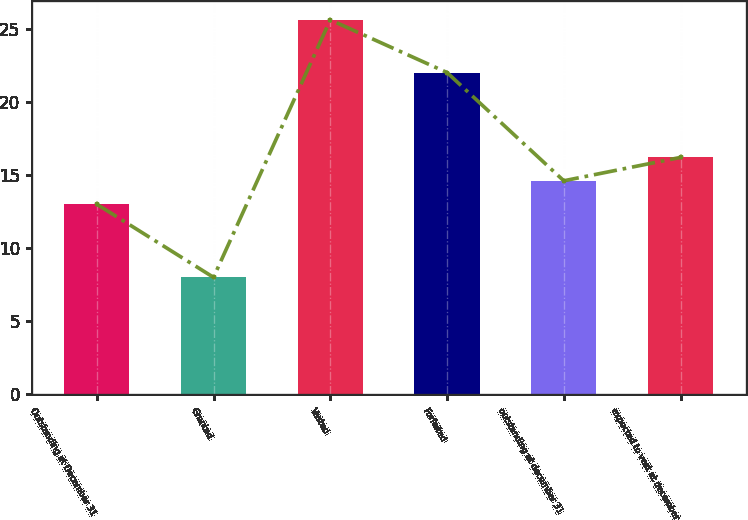<chart> <loc_0><loc_0><loc_500><loc_500><bar_chart><fcel>Outstanding at December 31<fcel>Granted<fcel>Vested<fcel>Forfeited<fcel>outstanding at december 31<fcel>expected to vest at december<nl><fcel>13<fcel>8<fcel>25.6<fcel>22<fcel>14.6<fcel>16.2<nl></chart> 